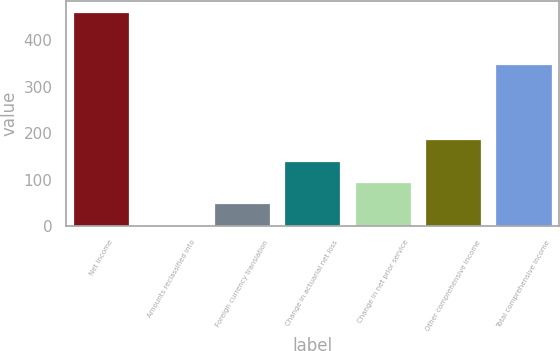Convert chart to OTSL. <chart><loc_0><loc_0><loc_500><loc_500><bar_chart><fcel>Net income<fcel>Amounts reclassified into<fcel>Foreign currency translation<fcel>Change in actuarial net loss<fcel>Change in net prior service<fcel>Other comprehensive income<fcel>Total comprehensive income<nl><fcel>462<fcel>3<fcel>48.9<fcel>140.7<fcel>94.8<fcel>186.6<fcel>350<nl></chart> 